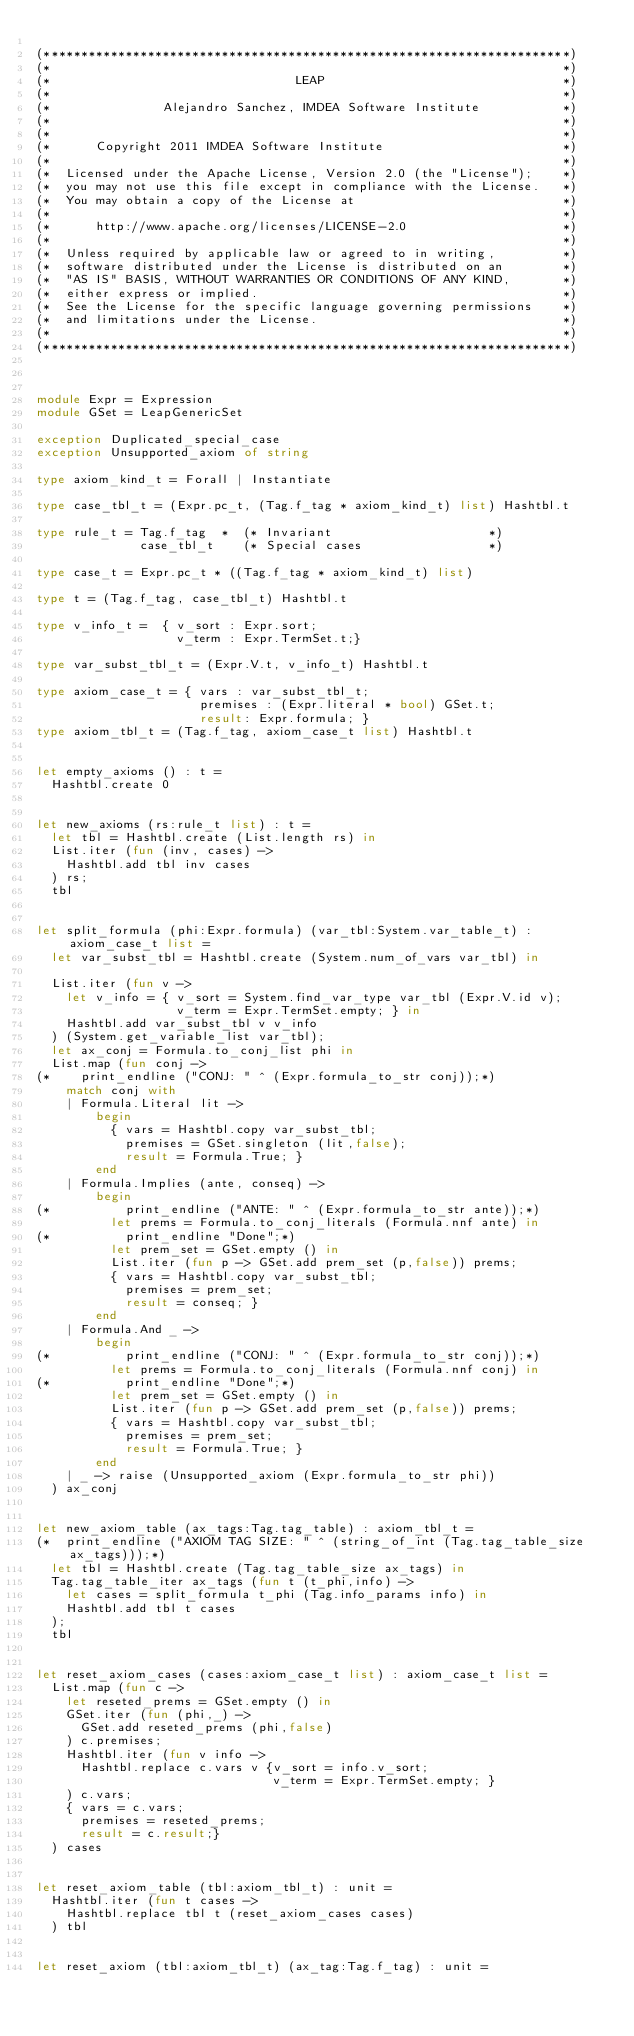Convert code to text. <code><loc_0><loc_0><loc_500><loc_500><_OCaml_>
(***********************************************************************)
(*                                                                     *)
(*                                 LEAP                                *)
(*                                                                     *)
(*               Alejandro Sanchez, IMDEA Software Institute           *)
(*                                                                     *)
(*                                                                     *)
(*      Copyright 2011 IMDEA Software Institute                        *)
(*                                                                     *)
(*  Licensed under the Apache License, Version 2.0 (the "License");    *)
(*  you may not use this file except in compliance with the License.   *)
(*  You may obtain a copy of the License at                            *)
(*                                                                     *)
(*      http://www.apache.org/licenses/LICENSE-2.0                     *)
(*                                                                     *)
(*  Unless required by applicable law or agreed to in writing,         *)
(*  software distributed under the License is distributed on an        *)
(*  "AS IS" BASIS, WITHOUT WARRANTIES OR CONDITIONS OF ANY KIND,       *)
(*  either express or implied.                                         *)
(*  See the License for the specific language governing permissions    *)
(*  and limitations under the License.                                 *)
(*                                                                     *)
(***********************************************************************)



module Expr = Expression
module GSet = LeapGenericSet

exception Duplicated_special_case
exception Unsupported_axiom of string

type axiom_kind_t = Forall | Instantiate

type case_tbl_t = (Expr.pc_t, (Tag.f_tag * axiom_kind_t) list) Hashtbl.t

type rule_t = Tag.f_tag  *  (* Invariant                     *)
              case_tbl_t    (* Special cases                 *)

type case_t = Expr.pc_t * ((Tag.f_tag * axiom_kind_t) list)

type t = (Tag.f_tag, case_tbl_t) Hashtbl.t

type v_info_t =  { v_sort : Expr.sort;
                   v_term : Expr.TermSet.t;}

type var_subst_tbl_t = (Expr.V.t, v_info_t) Hashtbl.t

type axiom_case_t = { vars : var_subst_tbl_t;
                      premises : (Expr.literal * bool) GSet.t;
                      result: Expr.formula; }
type axiom_tbl_t = (Tag.f_tag, axiom_case_t list) Hashtbl.t


let empty_axioms () : t =
  Hashtbl.create 0


let new_axioms (rs:rule_t list) : t =
  let tbl = Hashtbl.create (List.length rs) in
  List.iter (fun (inv, cases) ->
    Hashtbl.add tbl inv cases
  ) rs;
  tbl


let split_formula (phi:Expr.formula) (var_tbl:System.var_table_t) : axiom_case_t list =
  let var_subst_tbl = Hashtbl.create (System.num_of_vars var_tbl) in

  List.iter (fun v ->
    let v_info = { v_sort = System.find_var_type var_tbl (Expr.V.id v);
                   v_term = Expr.TermSet.empty; } in
    Hashtbl.add var_subst_tbl v v_info
  ) (System.get_variable_list var_tbl);
  let ax_conj = Formula.to_conj_list phi in
  List.map (fun conj ->
(*    print_endline ("CONJ: " ^ (Expr.formula_to_str conj));*)
    match conj with
    | Formula.Literal lit ->
        begin
          { vars = Hashtbl.copy var_subst_tbl;
            premises = GSet.singleton (lit,false);
            result = Formula.True; }
        end
    | Formula.Implies (ante, conseq) ->
        begin
(*          print_endline ("ANTE: " ^ (Expr.formula_to_str ante));*)
          let prems = Formula.to_conj_literals (Formula.nnf ante) in
(*          print_endline "Done";*)
          let prem_set = GSet.empty () in
          List.iter (fun p -> GSet.add prem_set (p,false)) prems;
          { vars = Hashtbl.copy var_subst_tbl;
            premises = prem_set;
            result = conseq; }
        end
    | Formula.And _ ->
        begin
(*          print_endline ("CONJ: " ^ (Expr.formula_to_str conj));*)
          let prems = Formula.to_conj_literals (Formula.nnf conj) in
(*          print_endline "Done";*)
          let prem_set = GSet.empty () in
          List.iter (fun p -> GSet.add prem_set (p,false)) prems;
          { vars = Hashtbl.copy var_subst_tbl;
            premises = prem_set;
            result = Formula.True; }
        end
    | _ -> raise (Unsupported_axiom (Expr.formula_to_str phi))
  ) ax_conj


let new_axiom_table (ax_tags:Tag.tag_table) : axiom_tbl_t =
(*  print_endline ("AXIOM TAG SIZE: " ^ (string_of_int (Tag.tag_table_size ax_tags)));*)
  let tbl = Hashtbl.create (Tag.tag_table_size ax_tags) in
  Tag.tag_table_iter ax_tags (fun t (t_phi,info) ->
    let cases = split_formula t_phi (Tag.info_params info) in
    Hashtbl.add tbl t cases
  );
  tbl


let reset_axiom_cases (cases:axiom_case_t list) : axiom_case_t list =
  List.map (fun c ->
    let reseted_prems = GSet.empty () in
    GSet.iter (fun (phi,_) ->
      GSet.add reseted_prems (phi,false)
    ) c.premises;
    Hashtbl.iter (fun v info ->
      Hashtbl.replace c.vars v {v_sort = info.v_sort;
                                v_term = Expr.TermSet.empty; }
    ) c.vars;
    { vars = c.vars;
      premises = reseted_prems;
      result = c.result;}
  ) cases


let reset_axiom_table (tbl:axiom_tbl_t) : unit =
  Hashtbl.iter (fun t cases ->
    Hashtbl.replace tbl t (reset_axiom_cases cases)
  ) tbl


let reset_axiom (tbl:axiom_tbl_t) (ax_tag:Tag.f_tag) : unit =</code> 